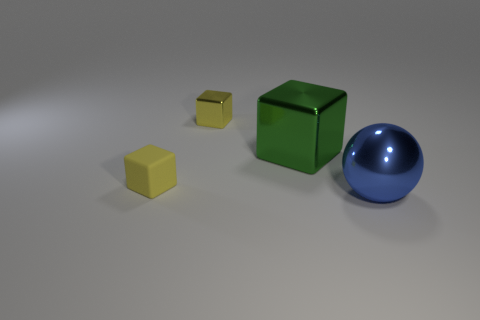Subtract all small yellow shiny blocks. How many blocks are left? 2 Subtract all green cubes. How many cubes are left? 2 Add 1 gray metal spheres. How many objects exist? 5 Subtract 3 blocks. How many blocks are left? 0 Subtract 0 brown cubes. How many objects are left? 4 Subtract all cubes. How many objects are left? 1 Subtract all brown balls. Subtract all brown cubes. How many balls are left? 1 Subtract all brown spheres. How many brown blocks are left? 0 Subtract all large spheres. Subtract all blocks. How many objects are left? 0 Add 3 shiny blocks. How many shiny blocks are left? 5 